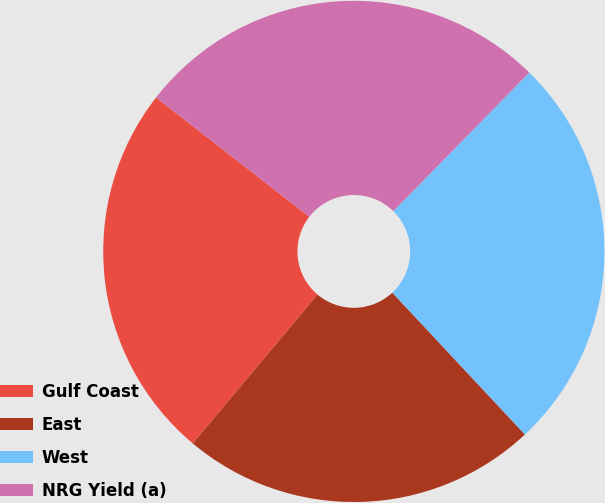Convert chart to OTSL. <chart><loc_0><loc_0><loc_500><loc_500><pie_chart><fcel>Gulf Coast<fcel>East<fcel>West<fcel>NRG Yield (a)<nl><fcel>24.42%<fcel>23.07%<fcel>25.69%<fcel>26.82%<nl></chart> 